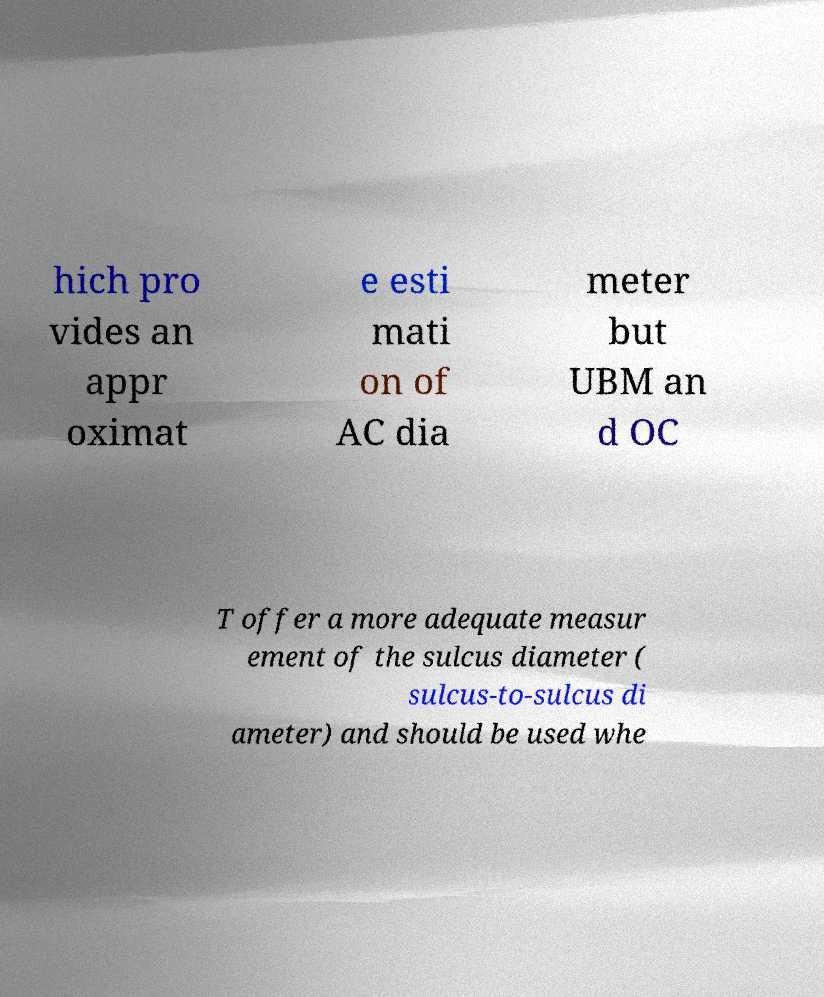Could you assist in decoding the text presented in this image and type it out clearly? hich pro vides an appr oximat e esti mati on of AC dia meter but UBM an d OC T offer a more adequate measur ement of the sulcus diameter ( sulcus-to-sulcus di ameter) and should be used whe 